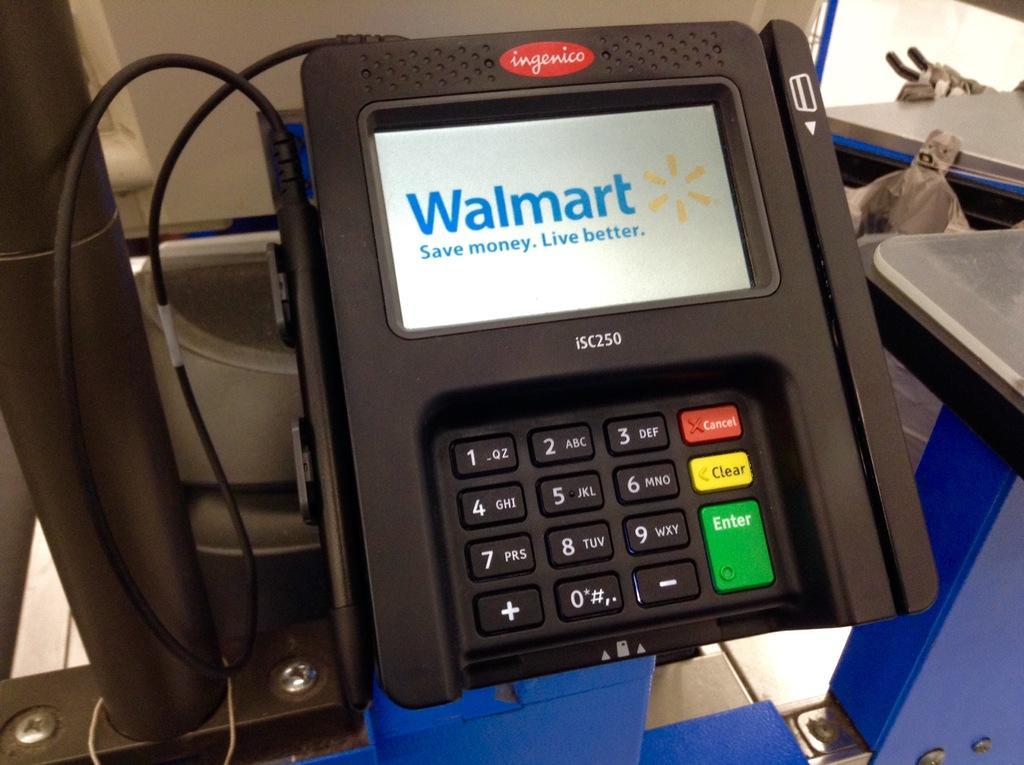Please provide a concise description of this image. In this image, we can see an electronic device. We can see some blue colored object at the bottom. We can also see a table on the right. We can see a pole and some metal objects. 